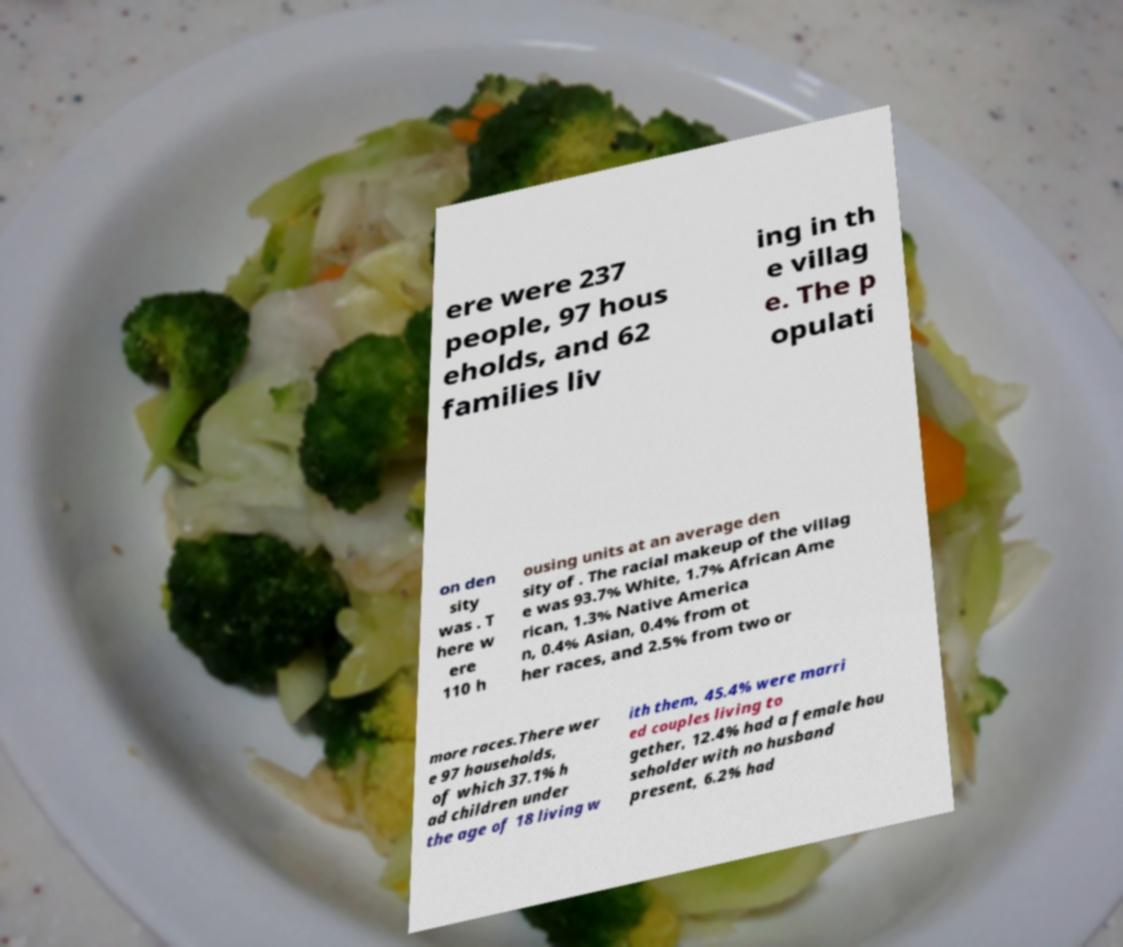What messages or text are displayed in this image? I need them in a readable, typed format. ere were 237 people, 97 hous eholds, and 62 families liv ing in th e villag e. The p opulati on den sity was . T here w ere 110 h ousing units at an average den sity of . The racial makeup of the villag e was 93.7% White, 1.7% African Ame rican, 1.3% Native America n, 0.4% Asian, 0.4% from ot her races, and 2.5% from two or more races.There wer e 97 households, of which 37.1% h ad children under the age of 18 living w ith them, 45.4% were marri ed couples living to gether, 12.4% had a female hou seholder with no husband present, 6.2% had 